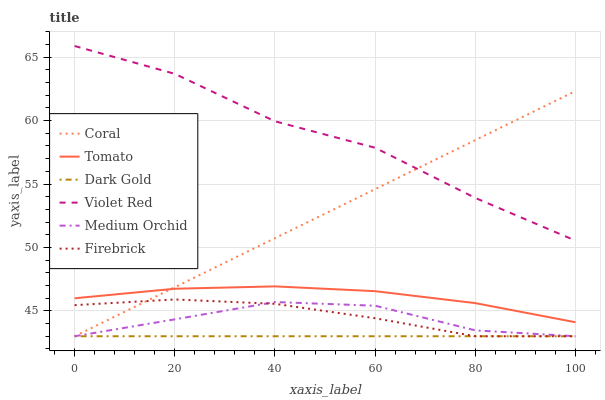Does Violet Red have the minimum area under the curve?
Answer yes or no. No. Does Dark Gold have the maximum area under the curve?
Answer yes or no. No. Is Violet Red the smoothest?
Answer yes or no. No. Is Dark Gold the roughest?
Answer yes or no. No. Does Violet Red have the lowest value?
Answer yes or no. No. Does Dark Gold have the highest value?
Answer yes or no. No. Is Dark Gold less than Tomato?
Answer yes or no. Yes. Is Tomato greater than Firebrick?
Answer yes or no. Yes. Does Dark Gold intersect Tomato?
Answer yes or no. No. 